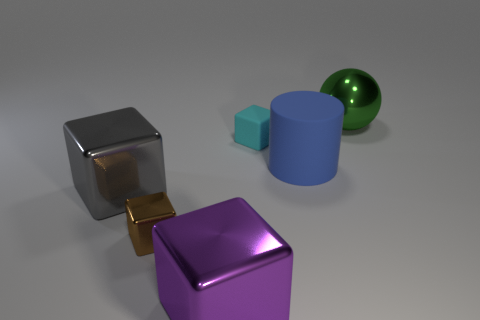Subtract 1 cubes. How many cubes are left? 3 Add 2 big blue blocks. How many objects exist? 8 Subtract all balls. How many objects are left? 5 Subtract 1 blue cylinders. How many objects are left? 5 Subtract all cylinders. Subtract all small brown things. How many objects are left? 4 Add 6 big purple metallic objects. How many big purple metallic objects are left? 7 Add 4 gray spheres. How many gray spheres exist? 4 